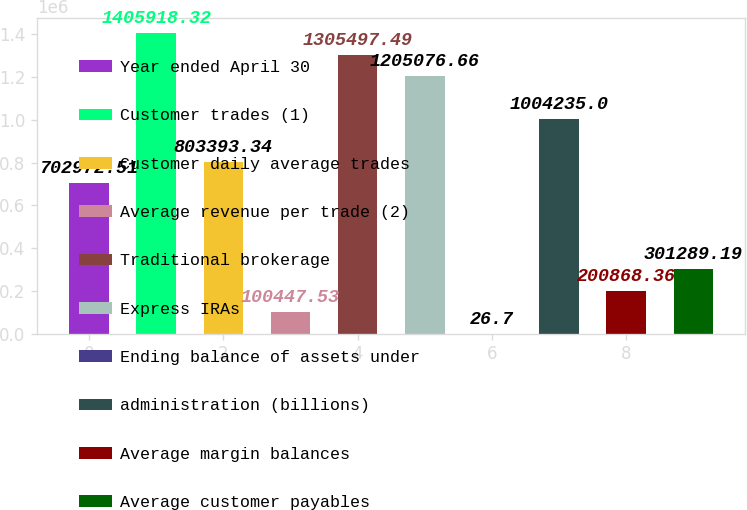<chart> <loc_0><loc_0><loc_500><loc_500><bar_chart><fcel>Year ended April 30<fcel>Customer trades (1)<fcel>Customer daily average trades<fcel>Average revenue per trade (2)<fcel>Traditional brokerage<fcel>Express IRAs<fcel>Ending balance of assets under<fcel>administration (billions)<fcel>Average margin balances<fcel>Average customer payables<nl><fcel>702973<fcel>1.40592e+06<fcel>803393<fcel>100448<fcel>1.3055e+06<fcel>1.20508e+06<fcel>26.7<fcel>1.00424e+06<fcel>200868<fcel>301289<nl></chart> 